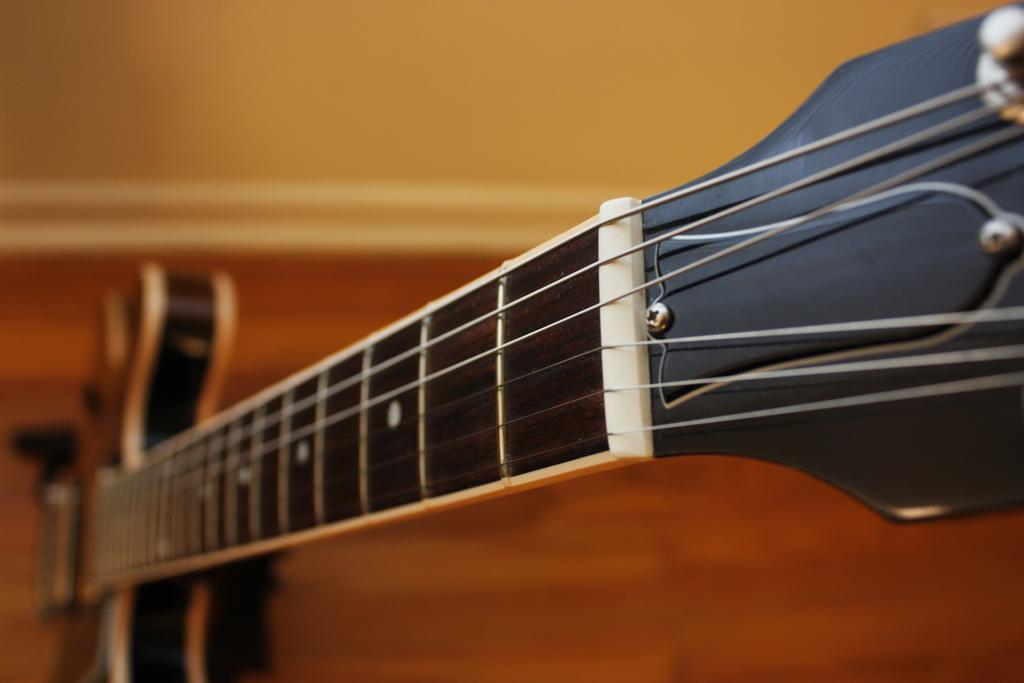What musical instrument is present in the image? There is a guitar in the image. What type of strings does the guitar have? The guitar in the image has six strings. What is the guitar's primary function? The guitar's primary function is to be played as a musical instrument. What part of the guitar is typically used to produce sound? The guitar's sound is produced by strumming or plucking the strings. How many cards are being played on the guitar in the image? There are no cards present in the image, and the guitar is not being used for playing cards. 